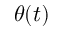Convert formula to latex. <formula><loc_0><loc_0><loc_500><loc_500>\theta ( t )</formula> 